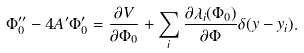<formula> <loc_0><loc_0><loc_500><loc_500>\Phi _ { 0 } ^ { \prime \prime } - 4 A ^ { \prime } \Phi _ { 0 } ^ { \prime } = \frac { \partial V } { \partial \Phi _ { 0 } } + \sum _ { i } \frac { \partial \lambda _ { i } ( \Phi _ { 0 } ) } { \partial \Phi } \delta ( y - y _ { i } ) .</formula> 